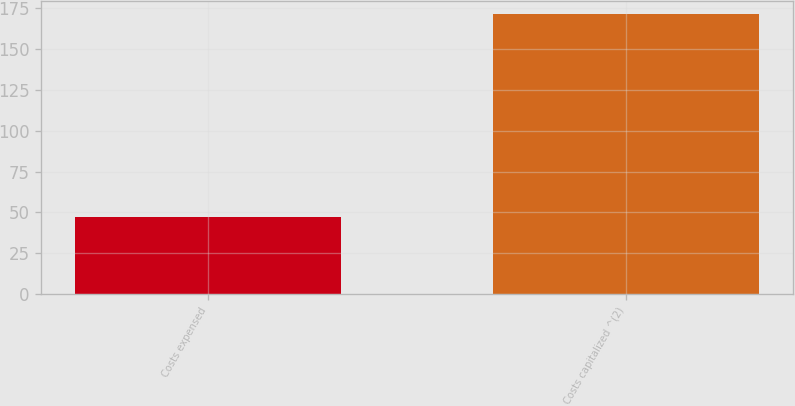<chart> <loc_0><loc_0><loc_500><loc_500><bar_chart><fcel>Costs expensed<fcel>Costs capitalized ^(2)<nl><fcel>47<fcel>171<nl></chart> 